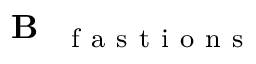<formula> <loc_0><loc_0><loc_500><loc_500>B _ { { f a s t i o n s } }</formula> 